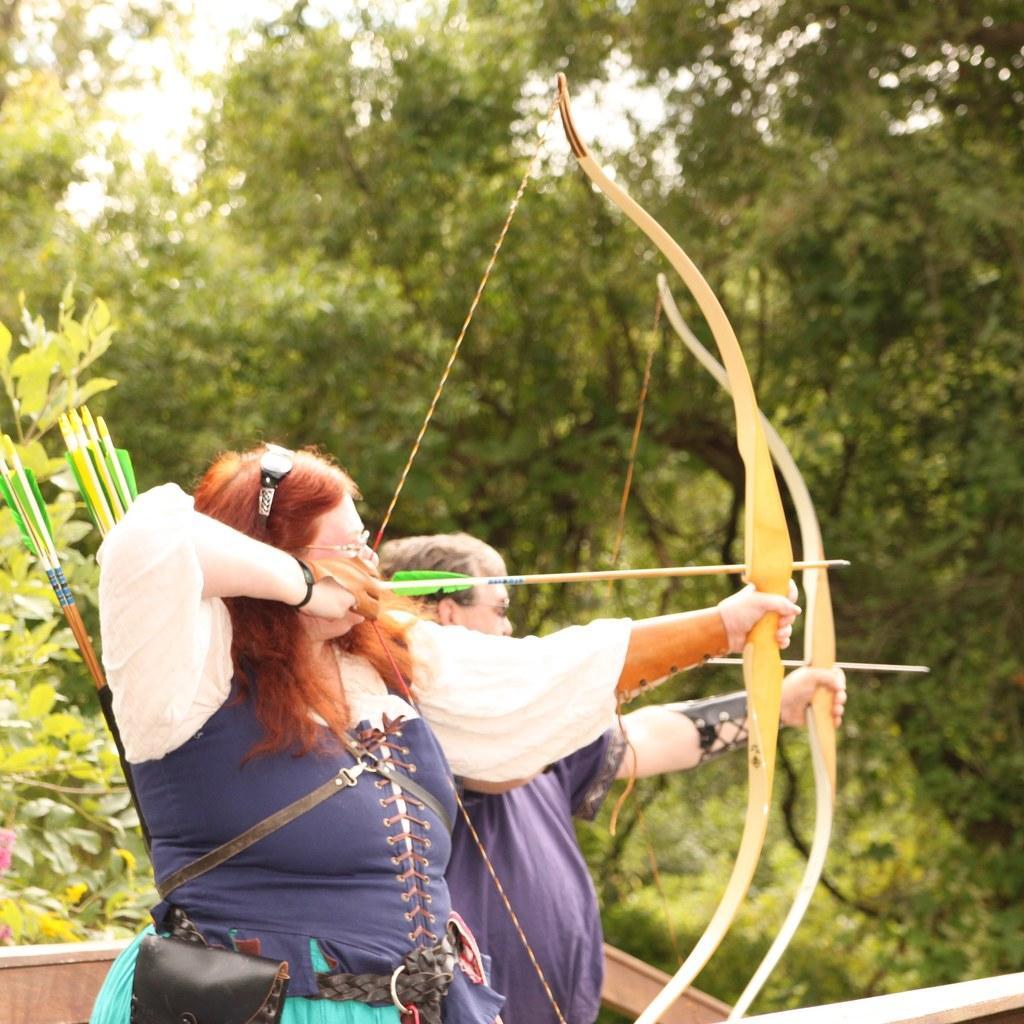Can you describe this image briefly? In front of the image there are two people holding the arrows and bows. In the background of the image there are trees. 